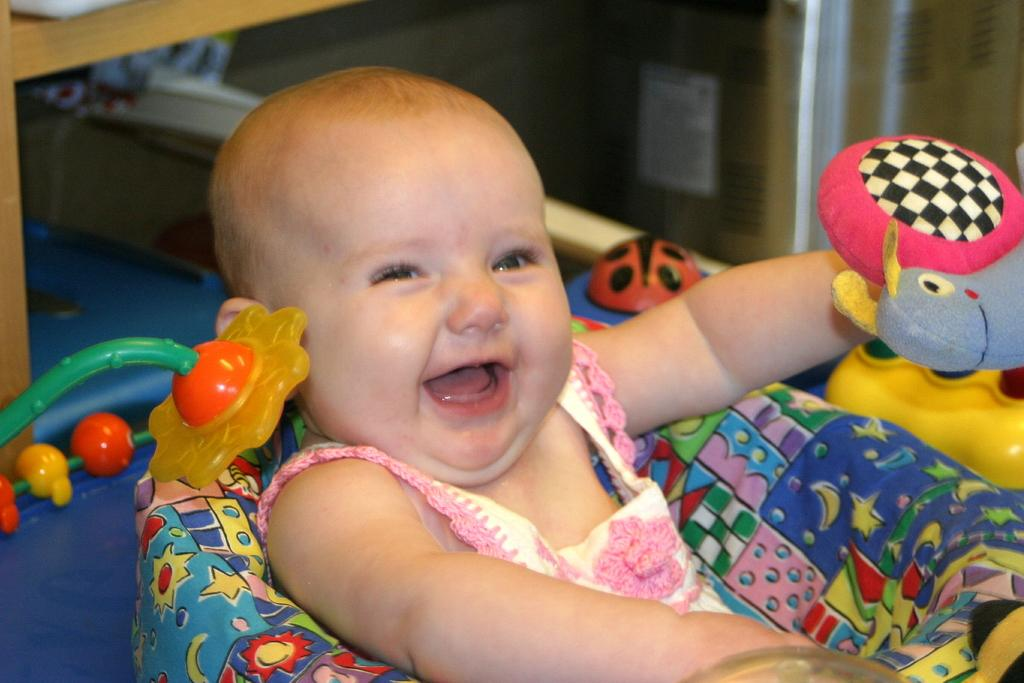What is the main subject of the image? The main subject of the image is a baby girl child. Where is the child located in the image? The child is in a small bed. What is the child doing in the image? The child is playing with a toy. What expression does the child have in the image? The child is smiling. What type of apparatus is being used by the child in the image? There is no apparatus present in the image; the child is playing with a toy. Can you see any flags in the image? There are no flags present in the image. 